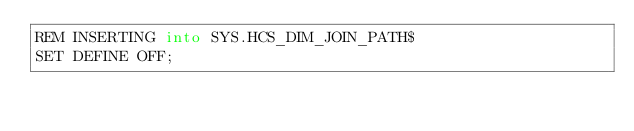<code> <loc_0><loc_0><loc_500><loc_500><_SQL_>REM INSERTING into SYS.HCS_DIM_JOIN_PATH$
SET DEFINE OFF;
</code> 